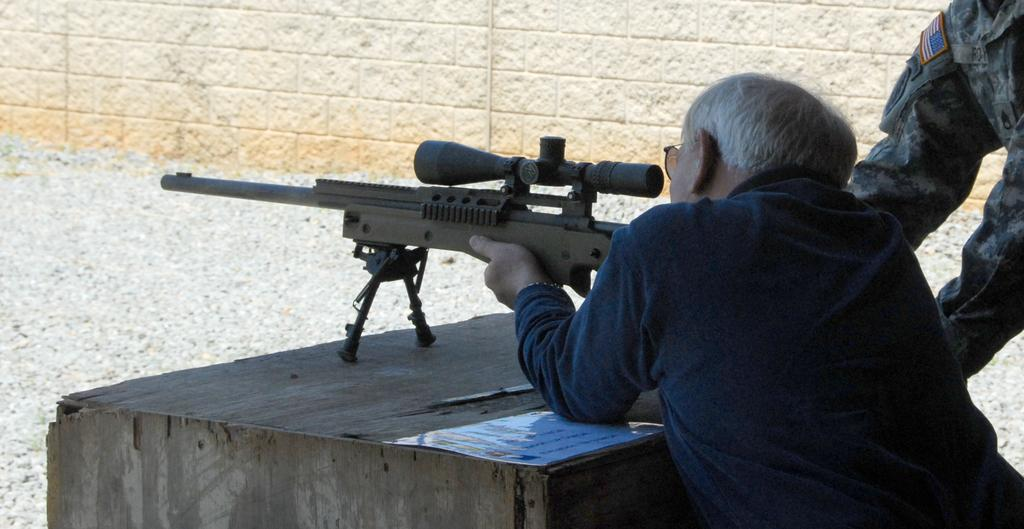What is the man in the image doing? The man is standing and looking through a sniper in the image. What can be seen in the background of the image? Walls and another person are visible in the background of the image. What type of crown is the man wearing in the image? There is no crown present in the image; the man is looking through a sniper. Can you see any animals in the image? There is no mention of animals or a zoo in the image; it features a man looking through a sniper and walls in the background. 